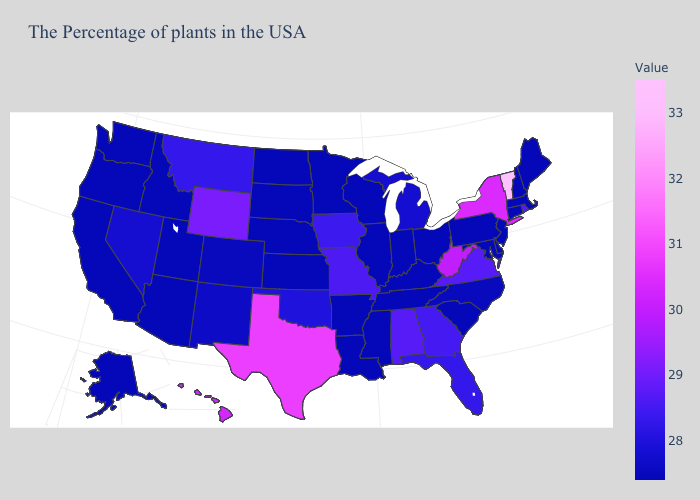Among the states that border Nevada , which have the highest value?
Answer briefly. Utah, Arizona, Idaho, California, Oregon. Does Texas have the highest value in the South?
Short answer required. Yes. Among the states that border Georgia , which have the lowest value?
Answer briefly. South Carolina, Tennessee. Does Idaho have the highest value in the West?
Be succinct. No. Which states have the lowest value in the USA?
Be succinct. Maine, Massachusetts, New Hampshire, Connecticut, New Jersey, Delaware, Maryland, Pennsylvania, South Carolina, Ohio, Kentucky, Indiana, Tennessee, Wisconsin, Illinois, Mississippi, Louisiana, Arkansas, Minnesota, Kansas, Nebraska, South Dakota, North Dakota, Utah, Arizona, Idaho, California, Washington, Oregon, Alaska. Among the states that border Washington , which have the lowest value?
Give a very brief answer. Idaho, Oregon. Among the states that border Minnesota , which have the highest value?
Answer briefly. Iowa. 